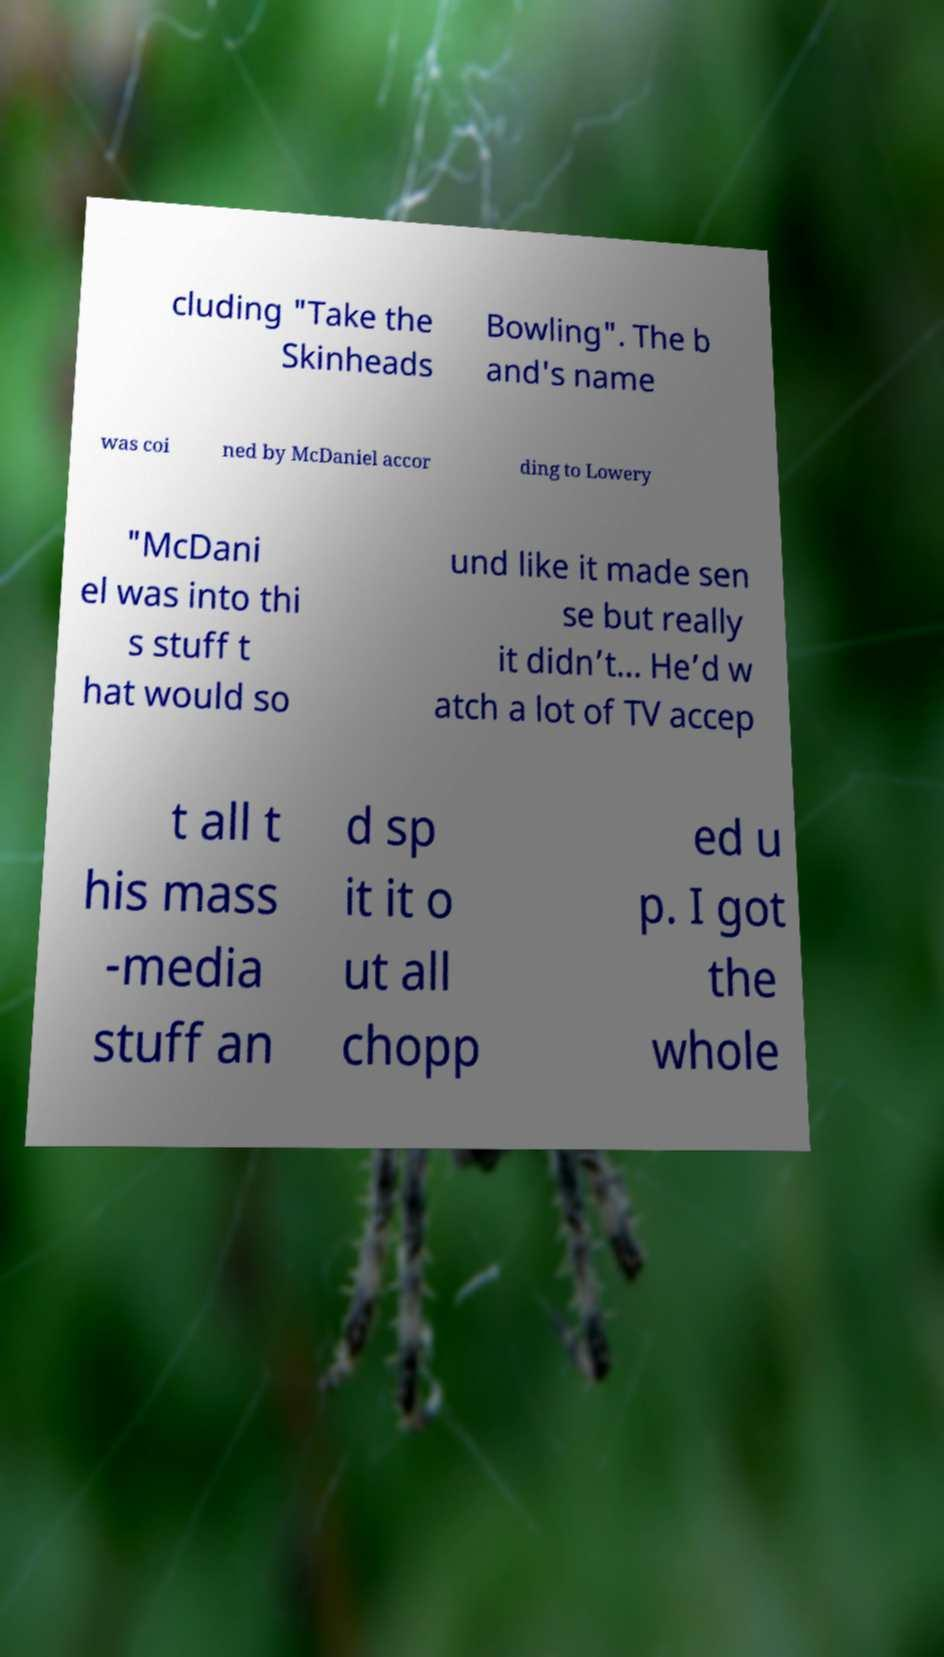Can you read and provide the text displayed in the image?This photo seems to have some interesting text. Can you extract and type it out for me? cluding "Take the Skinheads Bowling". The b and's name was coi ned by McDaniel accor ding to Lowery "McDani el was into thi s stuff t hat would so und like it made sen se but really it didn’t... He’d w atch a lot of TV accep t all t his mass -media stuff an d sp it it o ut all chopp ed u p. I got the whole 